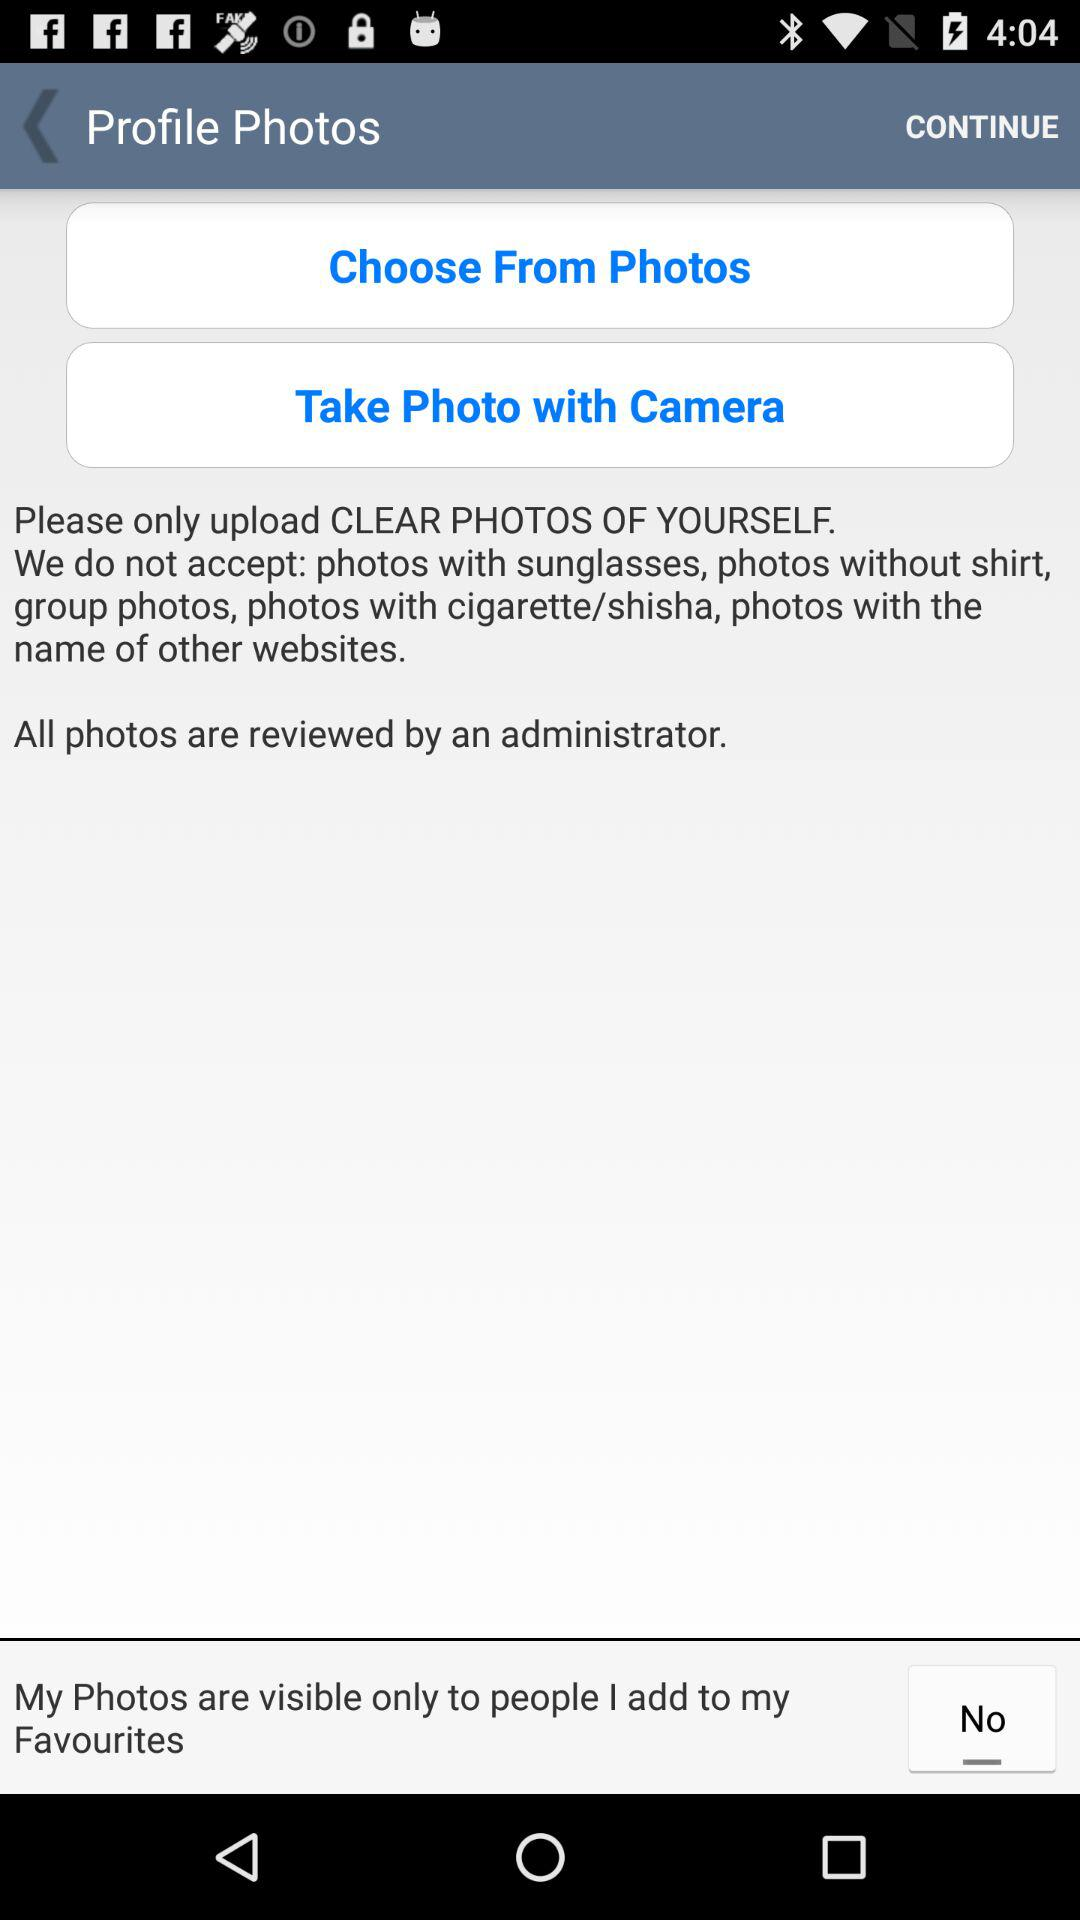Who reviewed all the photos? All the photos were reviewed by an administrator. 